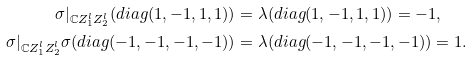Convert formula to latex. <formula><loc_0><loc_0><loc_500><loc_500>\sigma | _ { \mathbb { C } Z _ { 1 } ^ { l } Z _ { 2 } ^ { l } } ( d i a g ( 1 , - 1 , 1 , 1 ) ) & = \lambda ( d i a g ( 1 , - 1 , 1 , 1 ) ) = - 1 , \\ \sigma | _ { \mathbb { C } Z _ { 1 } ^ { l } Z _ { 2 } ^ { l } } \sigma ( d i a g ( - 1 , - 1 , - 1 , - 1 ) ) & = \lambda ( d i a g ( - 1 , - 1 , - 1 , - 1 ) ) = 1 .</formula> 